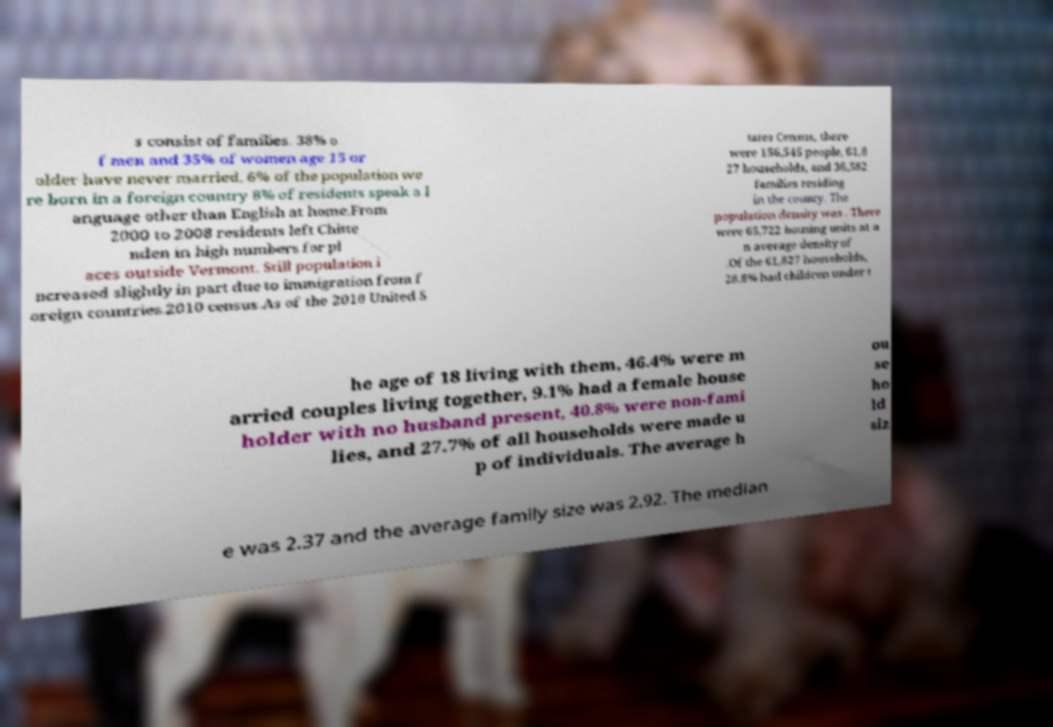Could you extract and type out the text from this image? s consist of families. 38% o f men and 35% of women age 15 or older have never married. 6% of the population we re born in a foreign country 8% of residents speak a l anguage other than English at home.From 2000 to 2008 residents left Chitte nden in high numbers for pl aces outside Vermont. Still population i ncreased slightly in part due to immigration from f oreign countries.2010 census.As of the 2010 United S tates Census, there were 156,545 people, 61,8 27 households, and 36,582 families residing in the county. The population density was . There were 65,722 housing units at a n average density of .Of the 61,827 households, 28.8% had children under t he age of 18 living with them, 46.4% were m arried couples living together, 9.1% had a female house holder with no husband present, 40.8% were non-fami lies, and 27.7% of all households were made u p of individuals. The average h ou se ho ld siz e was 2.37 and the average family size was 2.92. The median 